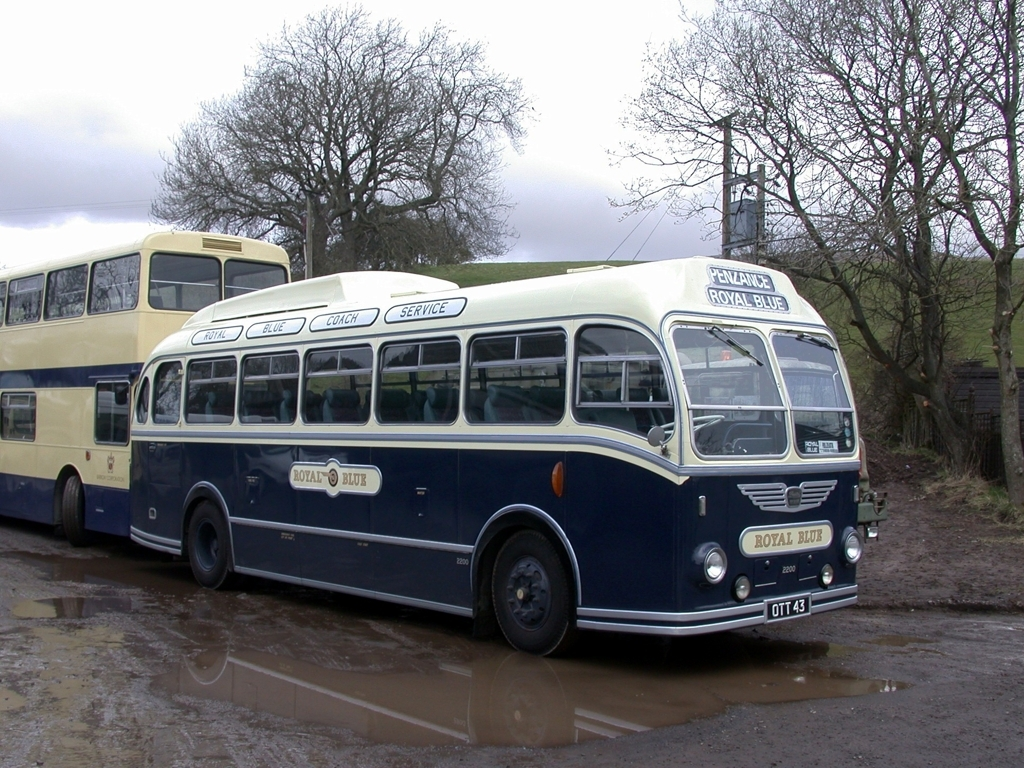Are the colors natural?
A. Unnatural
B. Distorted
C. Yes
D. Artificial
Answer with the option's letter from the given choices directly.
 C. 